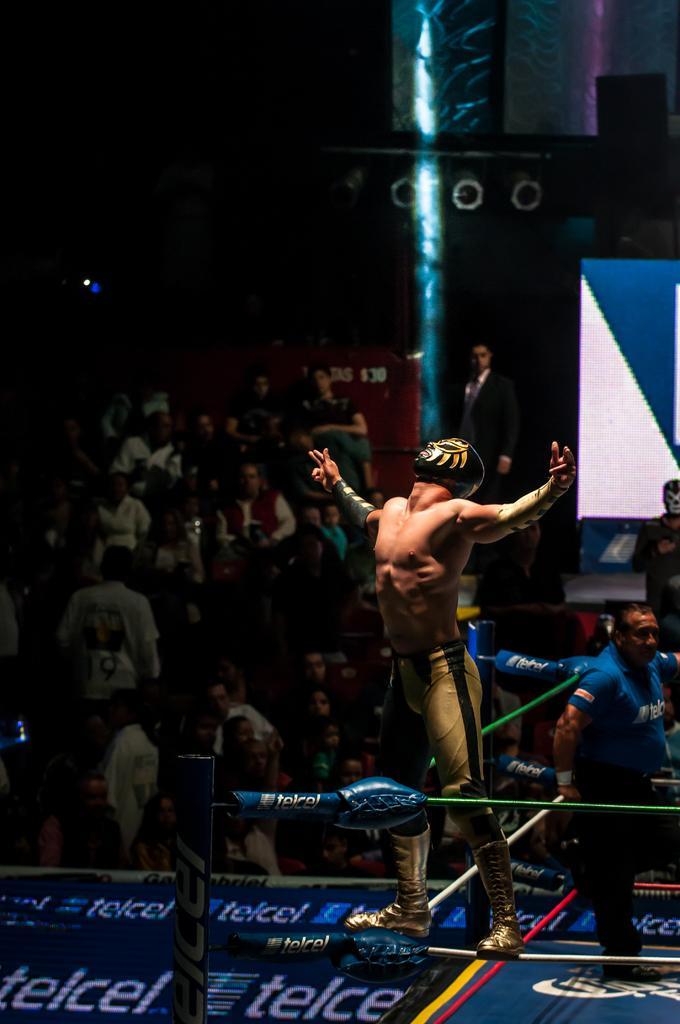Describe this image in one or two sentences. In this image, we can see a person on rope. There are some persons in the middle of the image. There is an another person in the bottom right of the image standing and wearing clothes. 